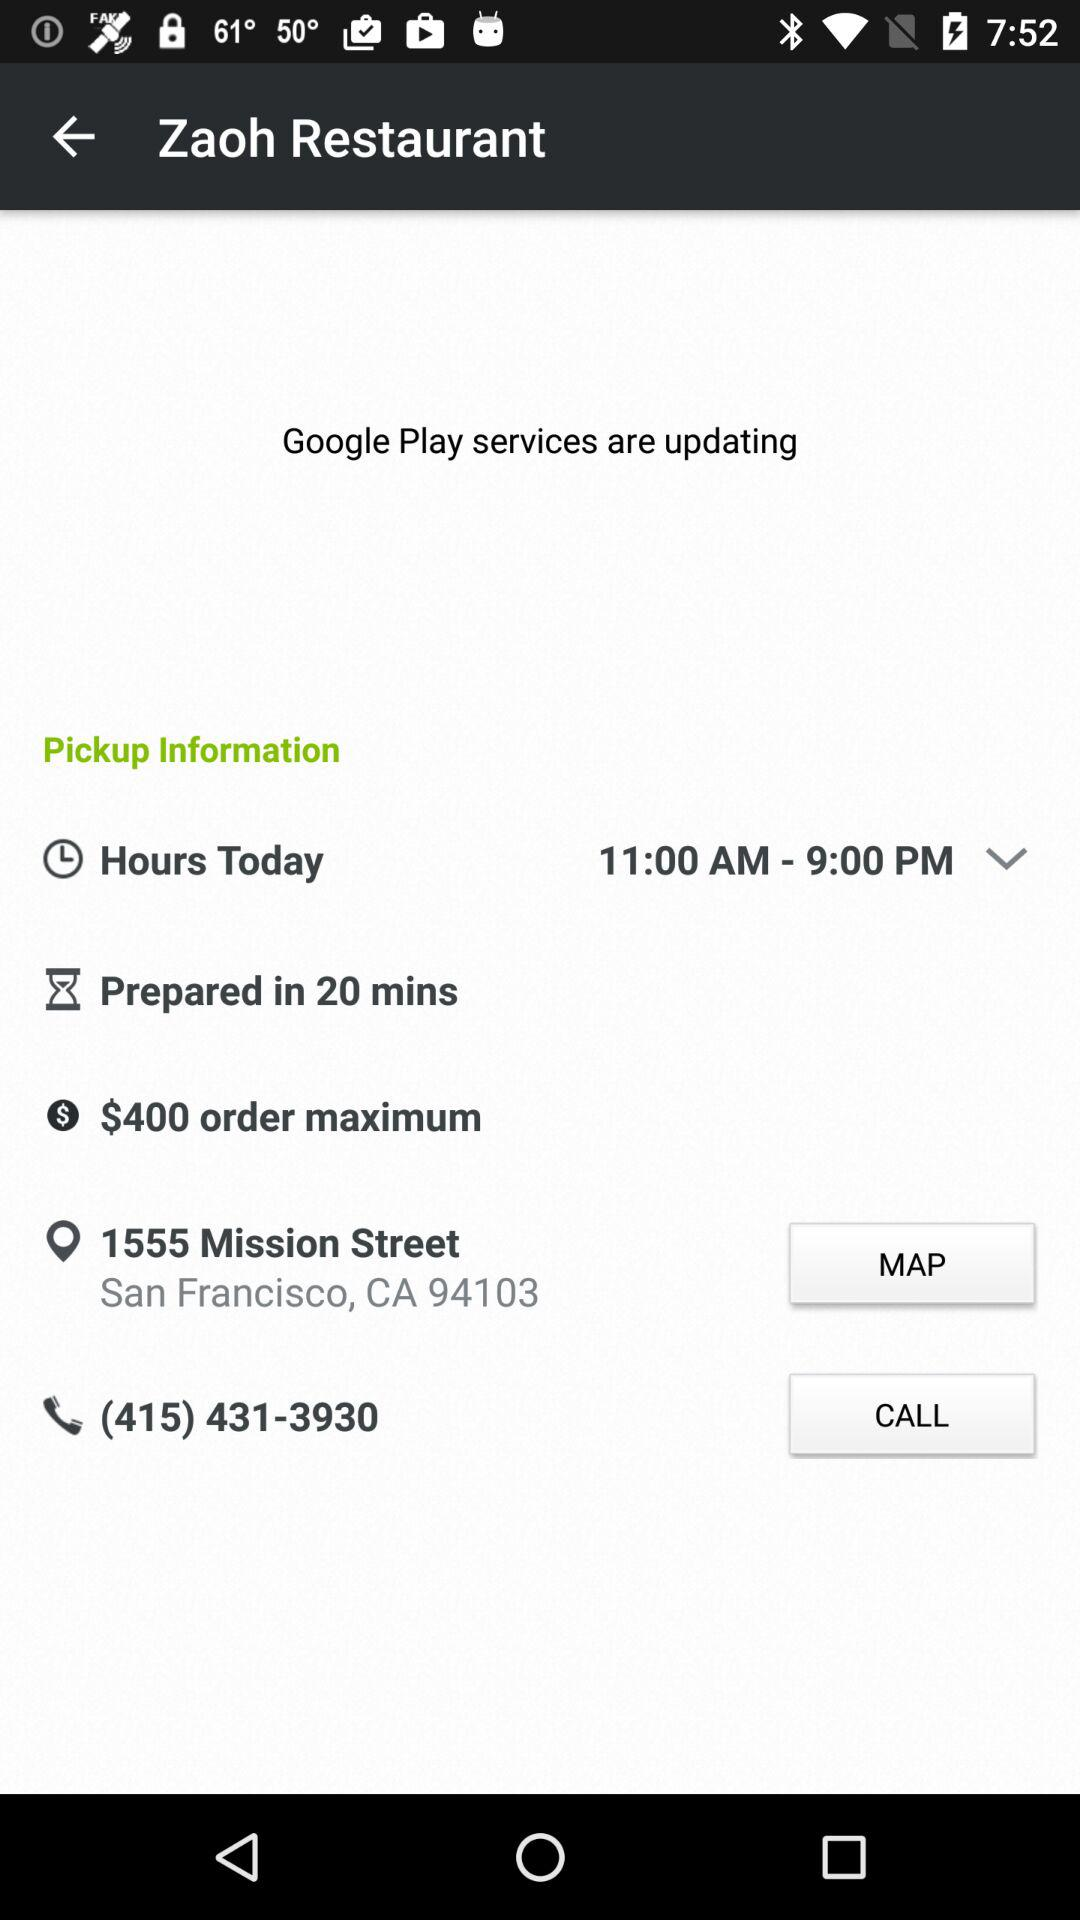What is the name of the restaurant? The name of the restaurant is "Zaoh Restaurant". 